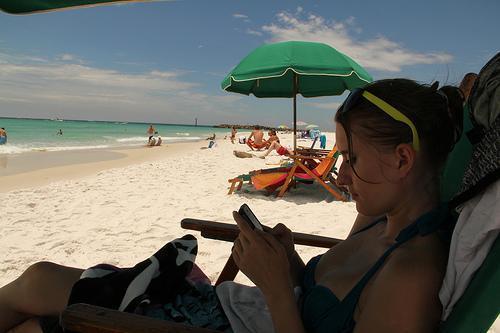How many people are in the water?
Give a very brief answer. 3. 